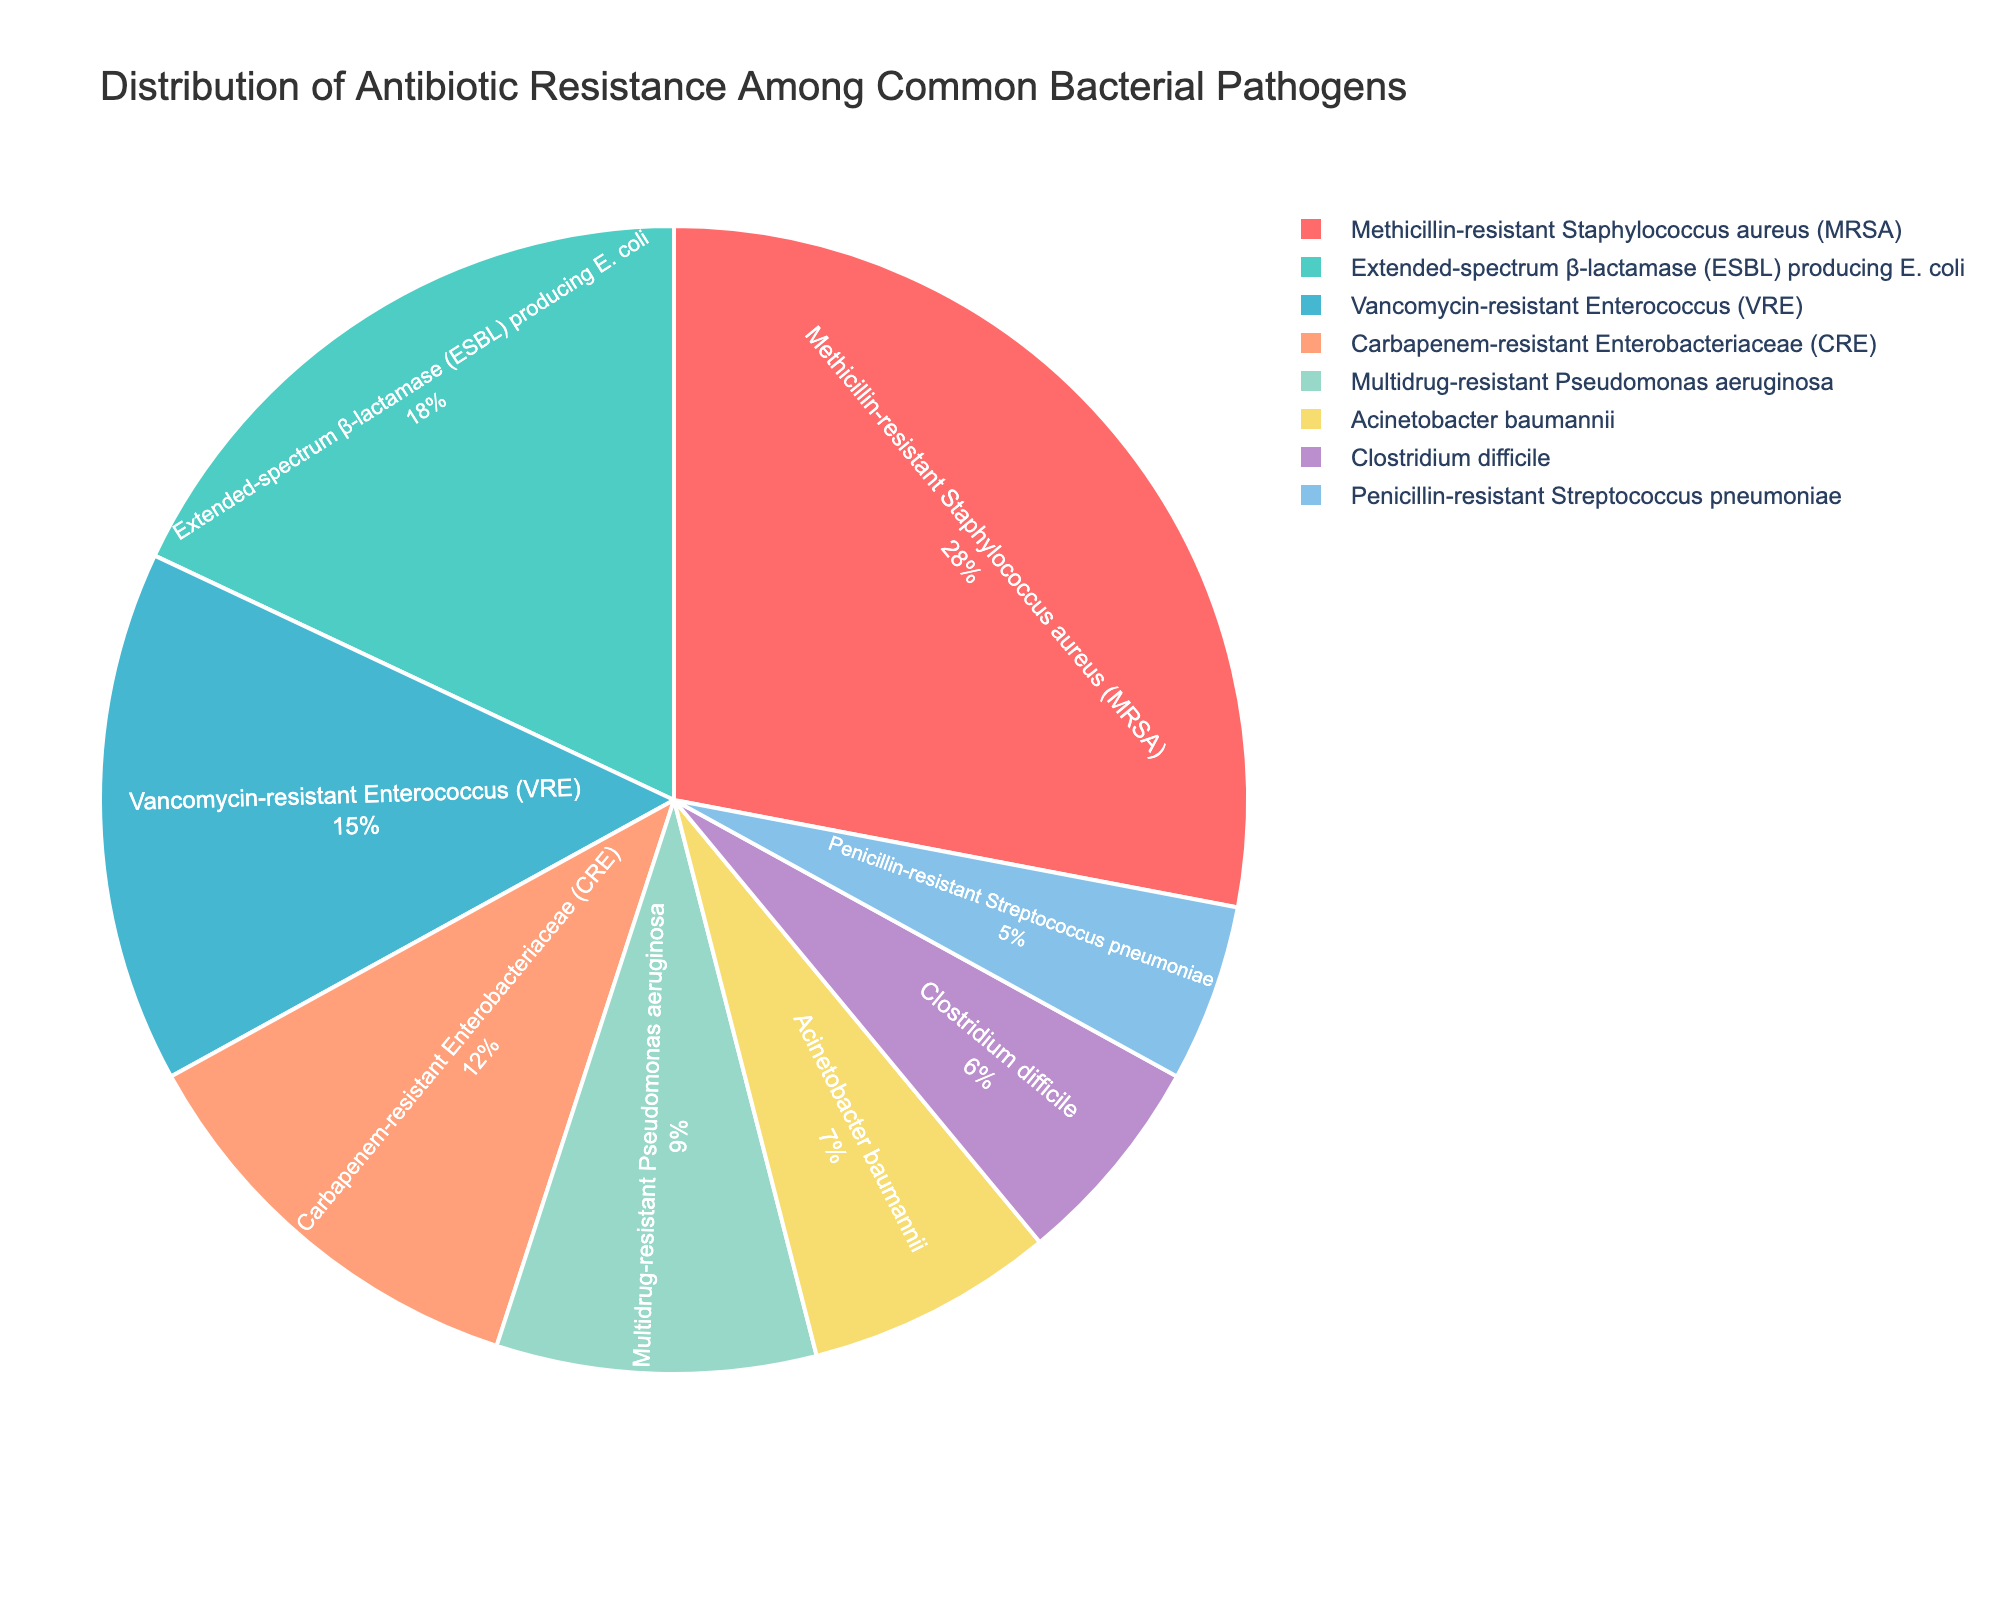Which pathogen has the highest percentage of antibiotic resistance? The pie chart shows various pathogens with their respective percentages of antibiotic resistance in different colors. The largest segment represents Methicillin-resistant Staphylococcus aureus (MRSA) which is 28%.
Answer: Methicillin-resistant Staphylococcus aureus (MRSA) Which two pathogens together make up more than 40% of antibiotic resistance cases? By checking the two largest percentages on the chart, Methicillin-resistant Staphylococcus aureus (MRSA) at 28% and Extended-spectrum β-lactamase (ESBL) producing E. coli at 18%, their sum is 28% + 18% = 46%.
Answer: Methicillin-resistant Staphylococcus aureus (MRSA) and Extended-spectrum β-lactamase (ESBL) producing E. coli Which pathogen has a higher resistance percentage: Vancomycin-resistant Enterococcus (VRE) or Carbapenem-resistant Enterobacteriaceae (CRE)? The pie chart indicates that Vancomycin-resistant Enterococcus (VRE) is 15% and Carbapenem-resistant Enterobacteriaceae (CRE) is 12%. 15% is higher than 12%.
Answer: Vancomycin-resistant Enterococcus (VRE) What is the combined percentage of Multidrug-resistant Pseudomonas aeruginosa and Acinetobacter baumannii? The chart shows that Multidrug-resistant Pseudomonas aeruginosa has 9% and Acinetobacter baumannii has 7%. Summing these values gives 9% + 7% = 16%.
Answer: 16% Which pathogen is represented by the smallest segment in the pie chart? From the pie chart, the smallest segment corresponds to Penicillin-resistant Streptococcus pneumoniae with 5%.
Answer: Penicillin-resistant Streptococcus pneumoniae What is the difference in percentage between the two least resistant pathogens? The two least resistant pathogens are Penicillin-resistant Streptococcus pneumoniae at 5% and Clostridium difficile at 6%. The difference is 6% - 5% = 1%.
Answer: 1% How many pathogens have an antibiotic resistance percentage greater than 10%? By counting the segments on the pie chart, the pathogens with a resistance percentage greater than 10% are Methicillin-resistant Staphylococcus aureus (MRSA) 28%, Vancomycin-resistant Enterococcus (VRE) 15%, Extended-spectrum β-lactamase (ESBL) producing E. coli 18%, and Carbapenem-resistant Enterobacteriaceae (CRE) 12%. There are four such pathogens.
Answer: 4 What is the average percentage of antibiotic resistance for Clostridium difficile, Acinetobacter baumannii, and Multidrug-resistant Pseudomonas aeruginosa? Sum the percentages: Clostridium difficile 6% + Acinetobacter baumannii 7% + Multidrug-resistant Pseudomonas aeruginosa 9%, which is 22%. Divide by 3 (because there are three pathogens): 22% / 3 ≈ 7.33%.
Answer: 7.33% Which pathogen's resistance percentage is closer to the median value of all listed pathogens' resistance percentages? Arrange the percentages in order: 5%, 6%, 7%, 9%, 12%, 15%, 18%, 28%. The median values are between 9% and 12%, so the median is (9% + 12%) / 2 = 10.5%. Closer resistance percentage to 10.5% is Multidrug-resistant Pseudomonas aeruginosa at 9%.
Answer: Multidrug-resistant Pseudomonas aeruginosa 